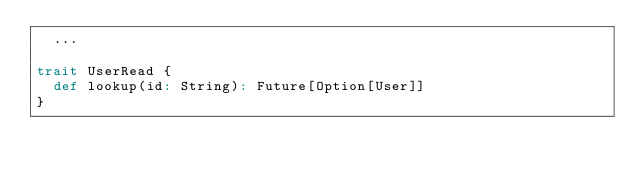Convert code to text. <code><loc_0><loc_0><loc_500><loc_500><_Scala_>  ...

trait UserRead {
  def lookup(id: String): Future[Option[User]]
}
</code> 